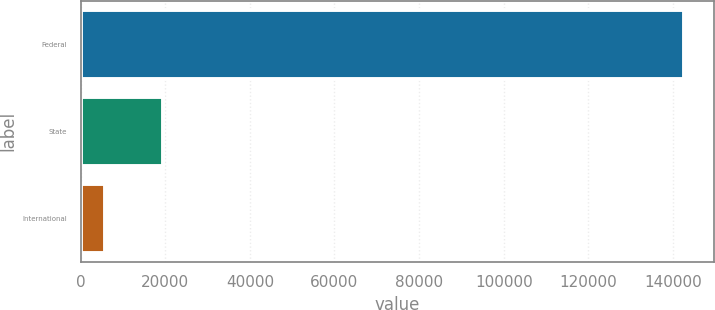<chart> <loc_0><loc_0><loc_500><loc_500><bar_chart><fcel>Federal<fcel>State<fcel>International<nl><fcel>142531<fcel>19484.8<fcel>5813<nl></chart> 